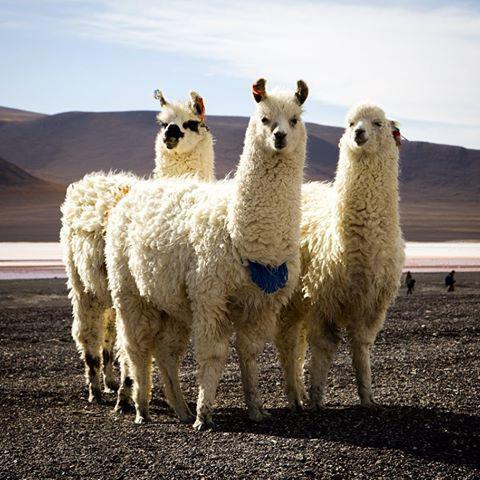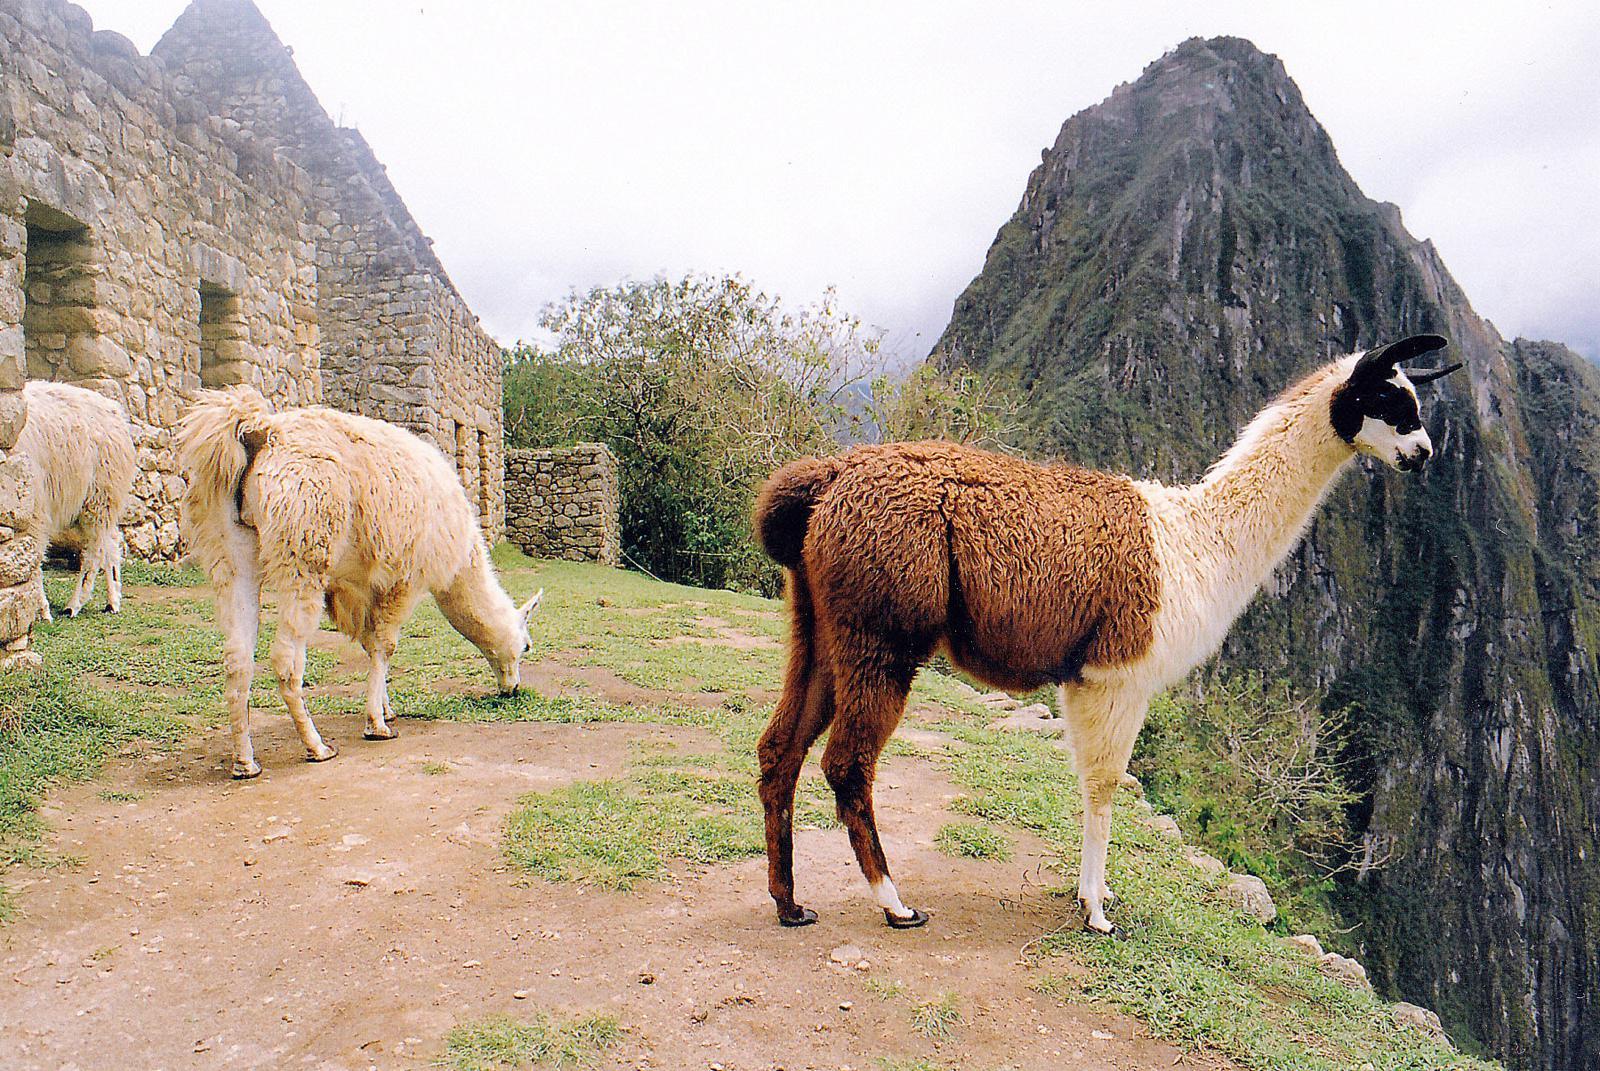The first image is the image on the left, the second image is the image on the right. Assess this claim about the two images: "There are three llamas in the left image.". Correct or not? Answer yes or no. Yes. The first image is the image on the left, the second image is the image on the right. Analyze the images presented: Is the assertion "The left image contains exactly three shaggy llamas standing in front of a brown hill, with at least one llama looking directly at the camera." valid? Answer yes or no. Yes. 